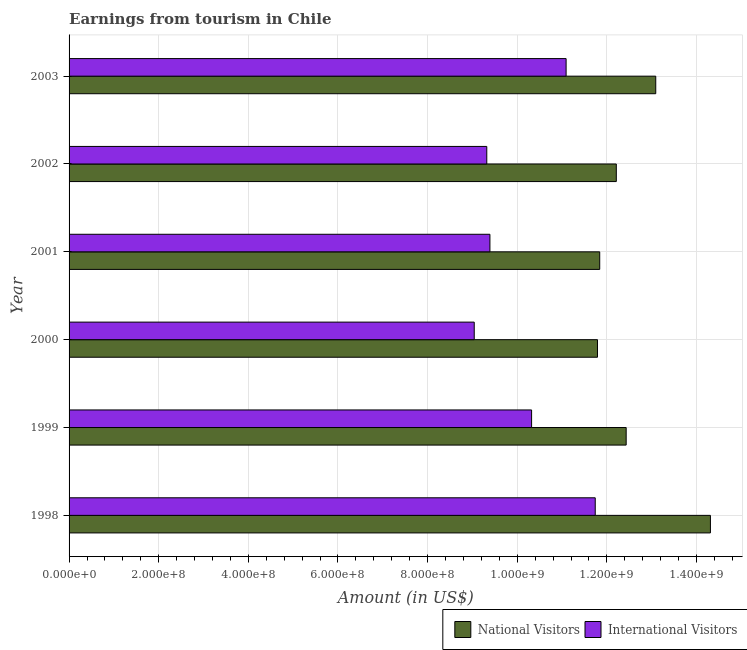How many different coloured bars are there?
Your answer should be very brief. 2. How many groups of bars are there?
Offer a terse response. 6. How many bars are there on the 2nd tick from the top?
Your answer should be very brief. 2. What is the label of the 4th group of bars from the top?
Give a very brief answer. 2000. In how many cases, is the number of bars for a given year not equal to the number of legend labels?
Offer a very short reply. 0. What is the amount earned from international visitors in 2000?
Ensure brevity in your answer.  9.04e+08. Across all years, what is the maximum amount earned from international visitors?
Keep it short and to the point. 1.17e+09. Across all years, what is the minimum amount earned from international visitors?
Make the answer very short. 9.04e+08. In which year was the amount earned from international visitors maximum?
Provide a succinct answer. 1998. In which year was the amount earned from international visitors minimum?
Your answer should be very brief. 2000. What is the total amount earned from national visitors in the graph?
Ensure brevity in your answer.  7.57e+09. What is the difference between the amount earned from national visitors in 1998 and that in 2001?
Your answer should be compact. 2.47e+08. What is the difference between the amount earned from national visitors in 1999 and the amount earned from international visitors in 1998?
Ensure brevity in your answer.  6.90e+07. What is the average amount earned from national visitors per year?
Offer a very short reply. 1.26e+09. In the year 2003, what is the difference between the amount earned from international visitors and amount earned from national visitors?
Offer a very short reply. -2.00e+08. What is the ratio of the amount earned from national visitors in 2000 to that in 2003?
Offer a terse response. 0.9. Is the amount earned from national visitors in 1999 less than that in 2002?
Your response must be concise. No. What is the difference between the highest and the second highest amount earned from international visitors?
Keep it short and to the point. 6.50e+07. What is the difference between the highest and the lowest amount earned from international visitors?
Give a very brief answer. 2.70e+08. What does the 1st bar from the top in 2000 represents?
Keep it short and to the point. International Visitors. What does the 2nd bar from the bottom in 2002 represents?
Provide a short and direct response. International Visitors. How many bars are there?
Ensure brevity in your answer.  12. What is the difference between two consecutive major ticks on the X-axis?
Make the answer very short. 2.00e+08. Are the values on the major ticks of X-axis written in scientific E-notation?
Offer a terse response. Yes. Does the graph contain grids?
Give a very brief answer. Yes. Where does the legend appear in the graph?
Your response must be concise. Bottom right. How many legend labels are there?
Your answer should be compact. 2. What is the title of the graph?
Your answer should be very brief. Earnings from tourism in Chile. Does "Under five" appear as one of the legend labels in the graph?
Offer a terse response. No. What is the label or title of the Y-axis?
Your answer should be very brief. Year. What is the Amount (in US$) of National Visitors in 1998?
Your answer should be very brief. 1.43e+09. What is the Amount (in US$) of International Visitors in 1998?
Offer a very short reply. 1.17e+09. What is the Amount (in US$) of National Visitors in 1999?
Provide a succinct answer. 1.24e+09. What is the Amount (in US$) of International Visitors in 1999?
Give a very brief answer. 1.03e+09. What is the Amount (in US$) in National Visitors in 2000?
Ensure brevity in your answer.  1.18e+09. What is the Amount (in US$) in International Visitors in 2000?
Provide a short and direct response. 9.04e+08. What is the Amount (in US$) of National Visitors in 2001?
Your answer should be compact. 1.18e+09. What is the Amount (in US$) of International Visitors in 2001?
Your response must be concise. 9.39e+08. What is the Amount (in US$) of National Visitors in 2002?
Give a very brief answer. 1.22e+09. What is the Amount (in US$) in International Visitors in 2002?
Offer a terse response. 9.32e+08. What is the Amount (in US$) of National Visitors in 2003?
Ensure brevity in your answer.  1.31e+09. What is the Amount (in US$) of International Visitors in 2003?
Provide a succinct answer. 1.11e+09. Across all years, what is the maximum Amount (in US$) in National Visitors?
Provide a succinct answer. 1.43e+09. Across all years, what is the maximum Amount (in US$) of International Visitors?
Your response must be concise. 1.17e+09. Across all years, what is the minimum Amount (in US$) of National Visitors?
Your response must be concise. 1.18e+09. Across all years, what is the minimum Amount (in US$) in International Visitors?
Offer a very short reply. 9.04e+08. What is the total Amount (in US$) in National Visitors in the graph?
Provide a short and direct response. 7.57e+09. What is the total Amount (in US$) in International Visitors in the graph?
Give a very brief answer. 6.09e+09. What is the difference between the Amount (in US$) in National Visitors in 1998 and that in 1999?
Your answer should be compact. 1.88e+08. What is the difference between the Amount (in US$) in International Visitors in 1998 and that in 1999?
Keep it short and to the point. 1.42e+08. What is the difference between the Amount (in US$) in National Visitors in 1998 and that in 2000?
Your response must be concise. 2.52e+08. What is the difference between the Amount (in US$) of International Visitors in 1998 and that in 2000?
Provide a short and direct response. 2.70e+08. What is the difference between the Amount (in US$) in National Visitors in 1998 and that in 2001?
Your answer should be very brief. 2.47e+08. What is the difference between the Amount (in US$) in International Visitors in 1998 and that in 2001?
Make the answer very short. 2.35e+08. What is the difference between the Amount (in US$) in National Visitors in 1998 and that in 2002?
Your response must be concise. 2.10e+08. What is the difference between the Amount (in US$) in International Visitors in 1998 and that in 2002?
Provide a short and direct response. 2.42e+08. What is the difference between the Amount (in US$) in National Visitors in 1998 and that in 2003?
Give a very brief answer. 1.22e+08. What is the difference between the Amount (in US$) of International Visitors in 1998 and that in 2003?
Ensure brevity in your answer.  6.50e+07. What is the difference between the Amount (in US$) of National Visitors in 1999 and that in 2000?
Offer a terse response. 6.40e+07. What is the difference between the Amount (in US$) in International Visitors in 1999 and that in 2000?
Give a very brief answer. 1.28e+08. What is the difference between the Amount (in US$) of National Visitors in 1999 and that in 2001?
Your answer should be very brief. 5.90e+07. What is the difference between the Amount (in US$) in International Visitors in 1999 and that in 2001?
Offer a very short reply. 9.30e+07. What is the difference between the Amount (in US$) of National Visitors in 1999 and that in 2002?
Your response must be concise. 2.20e+07. What is the difference between the Amount (in US$) of International Visitors in 1999 and that in 2002?
Your answer should be compact. 1.00e+08. What is the difference between the Amount (in US$) in National Visitors in 1999 and that in 2003?
Offer a terse response. -6.60e+07. What is the difference between the Amount (in US$) in International Visitors in 1999 and that in 2003?
Offer a very short reply. -7.70e+07. What is the difference between the Amount (in US$) of National Visitors in 2000 and that in 2001?
Keep it short and to the point. -5.00e+06. What is the difference between the Amount (in US$) of International Visitors in 2000 and that in 2001?
Make the answer very short. -3.50e+07. What is the difference between the Amount (in US$) in National Visitors in 2000 and that in 2002?
Provide a succinct answer. -4.20e+07. What is the difference between the Amount (in US$) of International Visitors in 2000 and that in 2002?
Your response must be concise. -2.80e+07. What is the difference between the Amount (in US$) in National Visitors in 2000 and that in 2003?
Provide a succinct answer. -1.30e+08. What is the difference between the Amount (in US$) of International Visitors in 2000 and that in 2003?
Your response must be concise. -2.05e+08. What is the difference between the Amount (in US$) of National Visitors in 2001 and that in 2002?
Give a very brief answer. -3.70e+07. What is the difference between the Amount (in US$) in International Visitors in 2001 and that in 2002?
Your response must be concise. 7.00e+06. What is the difference between the Amount (in US$) of National Visitors in 2001 and that in 2003?
Provide a succinct answer. -1.25e+08. What is the difference between the Amount (in US$) of International Visitors in 2001 and that in 2003?
Give a very brief answer. -1.70e+08. What is the difference between the Amount (in US$) of National Visitors in 2002 and that in 2003?
Give a very brief answer. -8.80e+07. What is the difference between the Amount (in US$) of International Visitors in 2002 and that in 2003?
Offer a terse response. -1.77e+08. What is the difference between the Amount (in US$) in National Visitors in 1998 and the Amount (in US$) in International Visitors in 1999?
Give a very brief answer. 3.99e+08. What is the difference between the Amount (in US$) of National Visitors in 1998 and the Amount (in US$) of International Visitors in 2000?
Provide a short and direct response. 5.27e+08. What is the difference between the Amount (in US$) in National Visitors in 1998 and the Amount (in US$) in International Visitors in 2001?
Make the answer very short. 4.92e+08. What is the difference between the Amount (in US$) of National Visitors in 1998 and the Amount (in US$) of International Visitors in 2002?
Keep it short and to the point. 4.99e+08. What is the difference between the Amount (in US$) of National Visitors in 1998 and the Amount (in US$) of International Visitors in 2003?
Provide a short and direct response. 3.22e+08. What is the difference between the Amount (in US$) of National Visitors in 1999 and the Amount (in US$) of International Visitors in 2000?
Keep it short and to the point. 3.39e+08. What is the difference between the Amount (in US$) in National Visitors in 1999 and the Amount (in US$) in International Visitors in 2001?
Provide a short and direct response. 3.04e+08. What is the difference between the Amount (in US$) in National Visitors in 1999 and the Amount (in US$) in International Visitors in 2002?
Offer a terse response. 3.11e+08. What is the difference between the Amount (in US$) in National Visitors in 1999 and the Amount (in US$) in International Visitors in 2003?
Make the answer very short. 1.34e+08. What is the difference between the Amount (in US$) of National Visitors in 2000 and the Amount (in US$) of International Visitors in 2001?
Offer a very short reply. 2.40e+08. What is the difference between the Amount (in US$) of National Visitors in 2000 and the Amount (in US$) of International Visitors in 2002?
Offer a very short reply. 2.47e+08. What is the difference between the Amount (in US$) of National Visitors in 2000 and the Amount (in US$) of International Visitors in 2003?
Provide a succinct answer. 7.00e+07. What is the difference between the Amount (in US$) of National Visitors in 2001 and the Amount (in US$) of International Visitors in 2002?
Make the answer very short. 2.52e+08. What is the difference between the Amount (in US$) in National Visitors in 2001 and the Amount (in US$) in International Visitors in 2003?
Your response must be concise. 7.50e+07. What is the difference between the Amount (in US$) of National Visitors in 2002 and the Amount (in US$) of International Visitors in 2003?
Keep it short and to the point. 1.12e+08. What is the average Amount (in US$) of National Visitors per year?
Your response must be concise. 1.26e+09. What is the average Amount (in US$) of International Visitors per year?
Your response must be concise. 1.02e+09. In the year 1998, what is the difference between the Amount (in US$) in National Visitors and Amount (in US$) in International Visitors?
Provide a succinct answer. 2.57e+08. In the year 1999, what is the difference between the Amount (in US$) in National Visitors and Amount (in US$) in International Visitors?
Provide a succinct answer. 2.11e+08. In the year 2000, what is the difference between the Amount (in US$) in National Visitors and Amount (in US$) in International Visitors?
Give a very brief answer. 2.75e+08. In the year 2001, what is the difference between the Amount (in US$) in National Visitors and Amount (in US$) in International Visitors?
Provide a short and direct response. 2.45e+08. In the year 2002, what is the difference between the Amount (in US$) of National Visitors and Amount (in US$) of International Visitors?
Keep it short and to the point. 2.89e+08. In the year 2003, what is the difference between the Amount (in US$) of National Visitors and Amount (in US$) of International Visitors?
Your response must be concise. 2.00e+08. What is the ratio of the Amount (in US$) of National Visitors in 1998 to that in 1999?
Provide a short and direct response. 1.15. What is the ratio of the Amount (in US$) in International Visitors in 1998 to that in 1999?
Offer a very short reply. 1.14. What is the ratio of the Amount (in US$) of National Visitors in 1998 to that in 2000?
Offer a very short reply. 1.21. What is the ratio of the Amount (in US$) in International Visitors in 1998 to that in 2000?
Provide a short and direct response. 1.3. What is the ratio of the Amount (in US$) of National Visitors in 1998 to that in 2001?
Offer a terse response. 1.21. What is the ratio of the Amount (in US$) in International Visitors in 1998 to that in 2001?
Your response must be concise. 1.25. What is the ratio of the Amount (in US$) of National Visitors in 1998 to that in 2002?
Offer a very short reply. 1.17. What is the ratio of the Amount (in US$) of International Visitors in 1998 to that in 2002?
Your response must be concise. 1.26. What is the ratio of the Amount (in US$) in National Visitors in 1998 to that in 2003?
Your answer should be very brief. 1.09. What is the ratio of the Amount (in US$) in International Visitors in 1998 to that in 2003?
Keep it short and to the point. 1.06. What is the ratio of the Amount (in US$) of National Visitors in 1999 to that in 2000?
Make the answer very short. 1.05. What is the ratio of the Amount (in US$) of International Visitors in 1999 to that in 2000?
Provide a short and direct response. 1.14. What is the ratio of the Amount (in US$) of National Visitors in 1999 to that in 2001?
Your response must be concise. 1.05. What is the ratio of the Amount (in US$) of International Visitors in 1999 to that in 2001?
Offer a terse response. 1.1. What is the ratio of the Amount (in US$) of International Visitors in 1999 to that in 2002?
Keep it short and to the point. 1.11. What is the ratio of the Amount (in US$) in National Visitors in 1999 to that in 2003?
Your answer should be compact. 0.95. What is the ratio of the Amount (in US$) in International Visitors in 1999 to that in 2003?
Offer a terse response. 0.93. What is the ratio of the Amount (in US$) of National Visitors in 2000 to that in 2001?
Provide a succinct answer. 1. What is the ratio of the Amount (in US$) of International Visitors in 2000 to that in 2001?
Ensure brevity in your answer.  0.96. What is the ratio of the Amount (in US$) in National Visitors in 2000 to that in 2002?
Ensure brevity in your answer.  0.97. What is the ratio of the Amount (in US$) of National Visitors in 2000 to that in 2003?
Give a very brief answer. 0.9. What is the ratio of the Amount (in US$) of International Visitors in 2000 to that in 2003?
Make the answer very short. 0.82. What is the ratio of the Amount (in US$) of National Visitors in 2001 to that in 2002?
Your answer should be very brief. 0.97. What is the ratio of the Amount (in US$) in International Visitors in 2001 to that in 2002?
Make the answer very short. 1.01. What is the ratio of the Amount (in US$) in National Visitors in 2001 to that in 2003?
Offer a terse response. 0.9. What is the ratio of the Amount (in US$) of International Visitors in 2001 to that in 2003?
Your answer should be very brief. 0.85. What is the ratio of the Amount (in US$) of National Visitors in 2002 to that in 2003?
Your answer should be very brief. 0.93. What is the ratio of the Amount (in US$) in International Visitors in 2002 to that in 2003?
Make the answer very short. 0.84. What is the difference between the highest and the second highest Amount (in US$) in National Visitors?
Keep it short and to the point. 1.22e+08. What is the difference between the highest and the second highest Amount (in US$) in International Visitors?
Offer a terse response. 6.50e+07. What is the difference between the highest and the lowest Amount (in US$) of National Visitors?
Your answer should be very brief. 2.52e+08. What is the difference between the highest and the lowest Amount (in US$) in International Visitors?
Provide a short and direct response. 2.70e+08. 